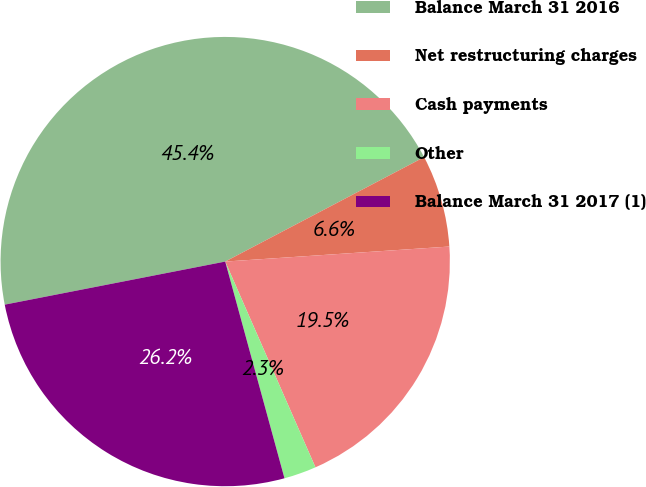Convert chart to OTSL. <chart><loc_0><loc_0><loc_500><loc_500><pie_chart><fcel>Balance March 31 2016<fcel>Net restructuring charges<fcel>Cash payments<fcel>Other<fcel>Balance March 31 2017 (1)<nl><fcel>45.38%<fcel>6.63%<fcel>19.49%<fcel>2.33%<fcel>26.18%<nl></chart> 